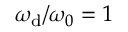<formula> <loc_0><loc_0><loc_500><loc_500>\omega _ { d } / \omega _ { 0 } = 1</formula> 